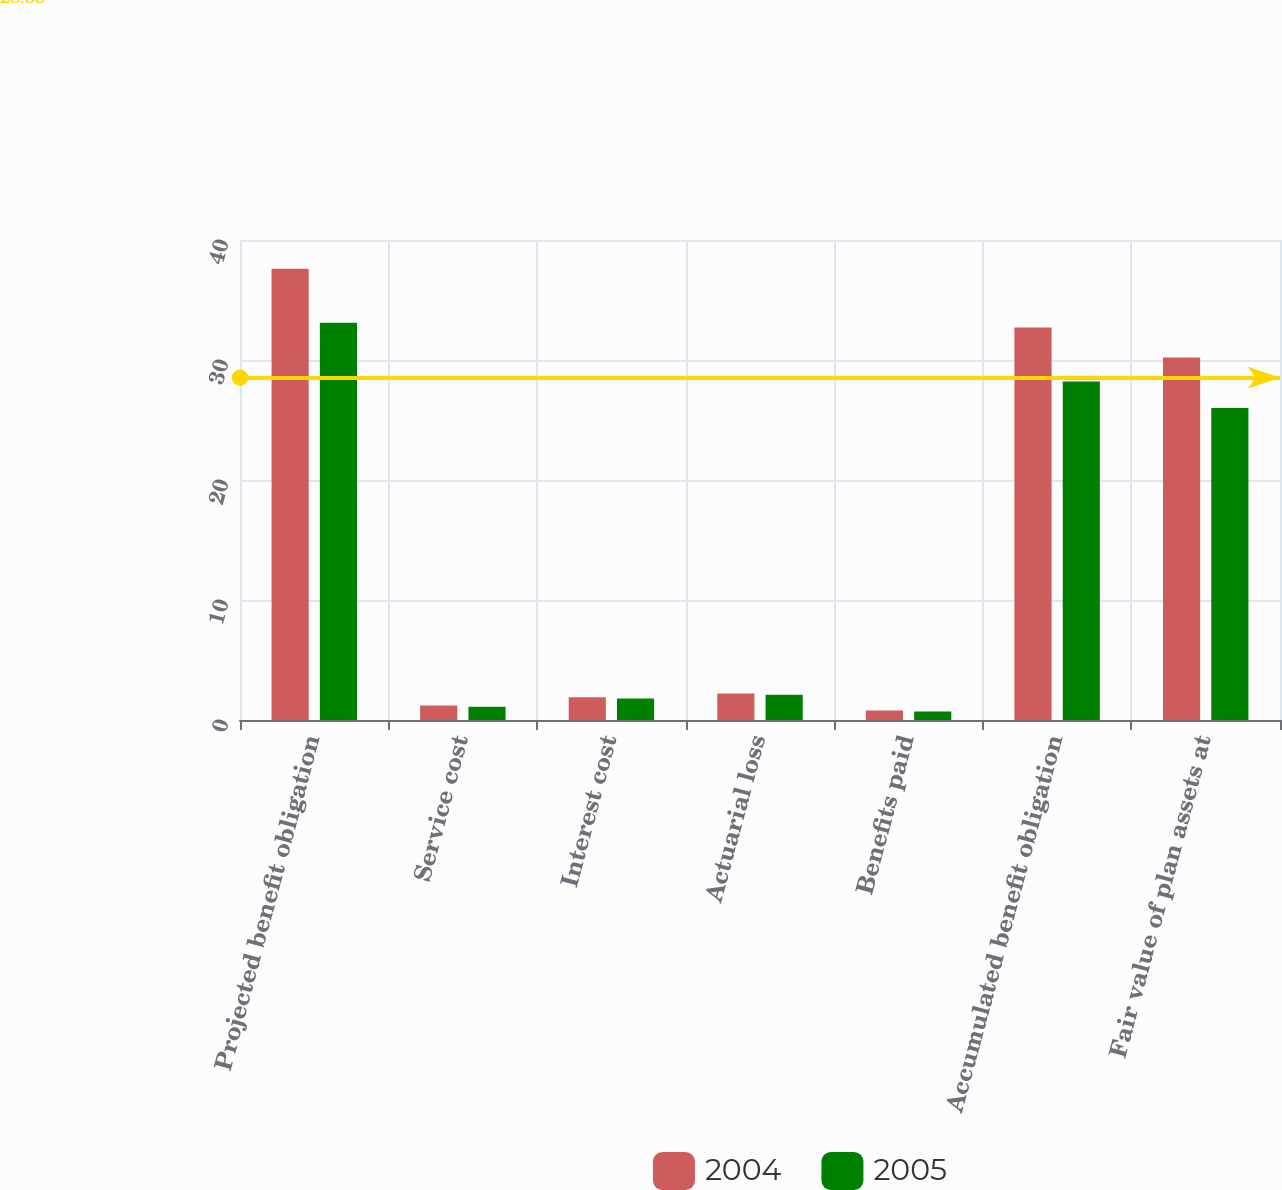Convert chart. <chart><loc_0><loc_0><loc_500><loc_500><stacked_bar_chart><ecel><fcel>Projected benefit obligation<fcel>Service cost<fcel>Interest cost<fcel>Actuarial loss<fcel>Benefits paid<fcel>Accumulated benefit obligation<fcel>Fair value of plan assets at<nl><fcel>2004<fcel>37.6<fcel>1.2<fcel>1.9<fcel>2.2<fcel>0.8<fcel>32.7<fcel>30.2<nl><fcel>2005<fcel>33.1<fcel>1.1<fcel>1.8<fcel>2.1<fcel>0.7<fcel>28.2<fcel>26<nl></chart> 